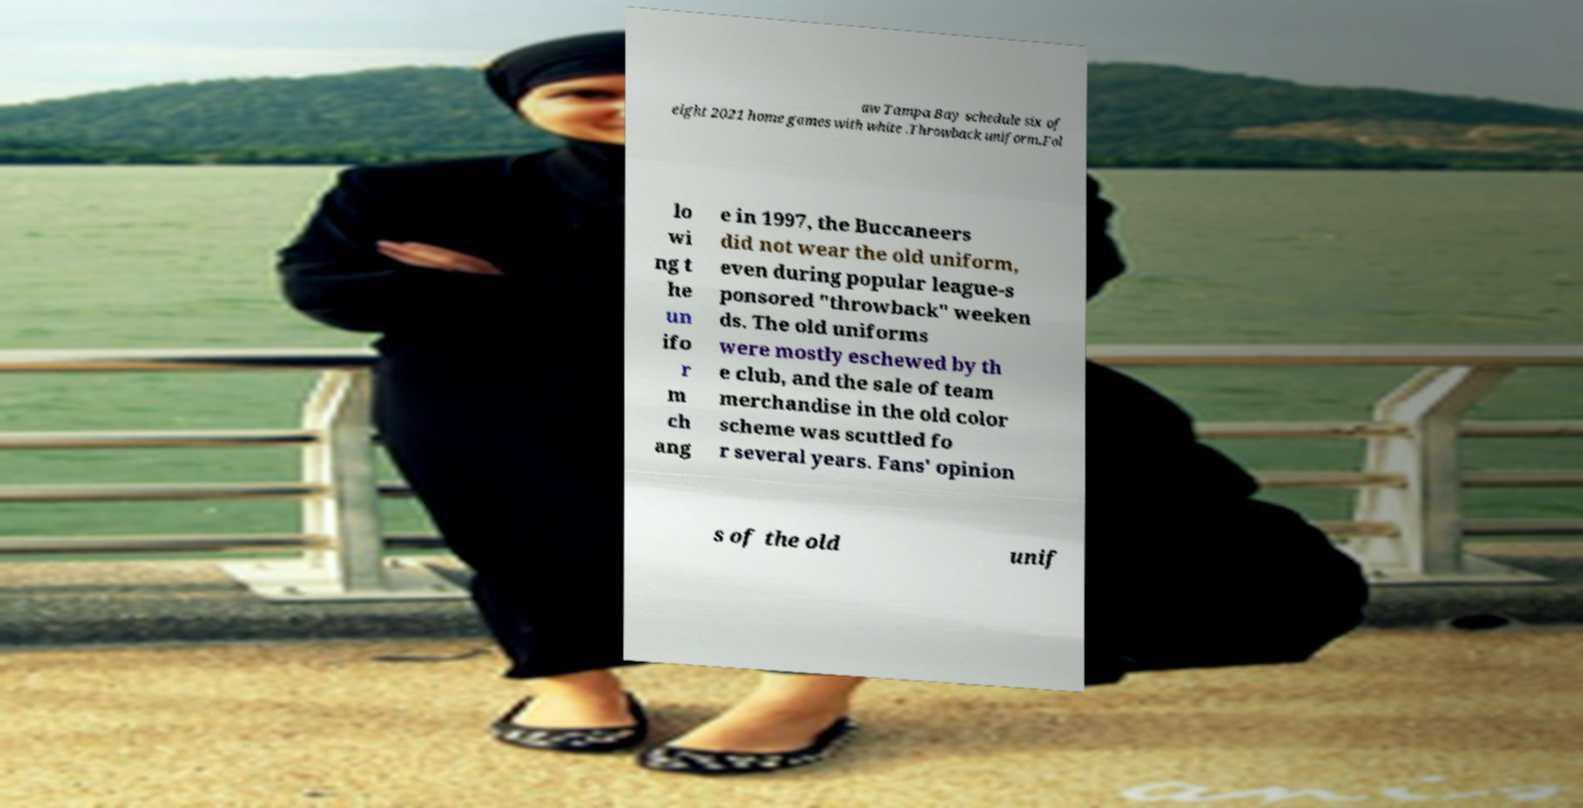Could you assist in decoding the text presented in this image and type it out clearly? aw Tampa Bay schedule six of eight 2021 home games with white .Throwback uniform.Fol lo wi ng t he un ifo r m ch ang e in 1997, the Buccaneers did not wear the old uniform, even during popular league-s ponsored "throwback" weeken ds. The old uniforms were mostly eschewed by th e club, and the sale of team merchandise in the old color scheme was scuttled fo r several years. Fans' opinion s of the old unif 